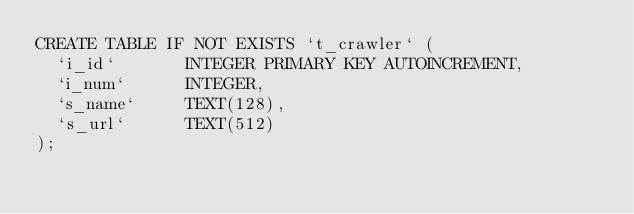<code> <loc_0><loc_0><loc_500><loc_500><_SQL_>CREATE TABLE IF NOT EXISTS `t_crawler` (
  `i_id`       INTEGER PRIMARY KEY AUTOINCREMENT,
  `i_num`      INTEGER,
  `s_name`     TEXT(128),
  `s_url`      TEXT(512)
);</code> 